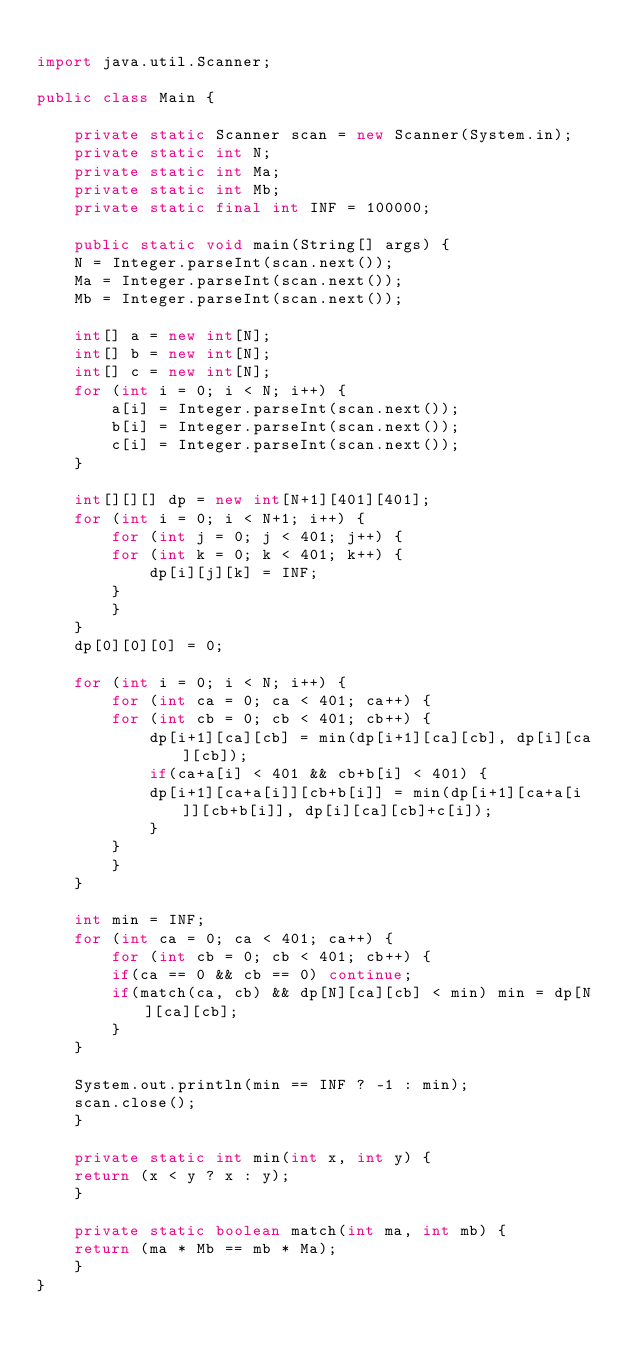Convert code to text. <code><loc_0><loc_0><loc_500><loc_500><_Java_>
import java.util.Scanner;

public class Main {

    private static Scanner scan = new Scanner(System.in);
    private static int N;
    private static int Ma;
    private static int Mb;
    private static final int INF = 100000;

    public static void main(String[] args) {
	N = Integer.parseInt(scan.next());
	Ma = Integer.parseInt(scan.next());
	Mb = Integer.parseInt(scan.next());

	int[] a = new int[N];
	int[] b = new int[N];
	int[] c = new int[N];
	for (int i = 0; i < N; i++) {
	    a[i] = Integer.parseInt(scan.next());
	    b[i] = Integer.parseInt(scan.next());
	    c[i] = Integer.parseInt(scan.next());
	}

	int[][][] dp = new int[N+1][401][401];
	for (int i = 0; i < N+1; i++) {
	    for (int j = 0; j < 401; j++) {
		for (int k = 0; k < 401; k++) {
		    dp[i][j][k] = INF;
		}
	    }
	}
	dp[0][0][0] = 0;

	for (int i = 0; i < N; i++) {
	    for (int ca = 0; ca < 401; ca++) {
		for (int cb = 0; cb < 401; cb++) {
		    dp[i+1][ca][cb] = min(dp[i+1][ca][cb], dp[i][ca][cb]);
		    if(ca+a[i] < 401 && cb+b[i] < 401) {
			dp[i+1][ca+a[i]][cb+b[i]] = min(dp[i+1][ca+a[i]][cb+b[i]], dp[i][ca][cb]+c[i]);
		    }
		}
	    }
	}

	int min = INF;
	for (int ca = 0; ca < 401; ca++) {
	    for (int cb = 0; cb < 401; cb++) {
		if(ca == 0 && cb == 0) continue;
		if(match(ca, cb) && dp[N][ca][cb] < min) min = dp[N][ca][cb];
	    }
	}

	System.out.println(min == INF ? -1 : min);
	scan.close();
    }

    private static int min(int x, int y) {
	return (x < y ? x : y);
    }

    private static boolean match(int ma, int mb) {
	return (ma * Mb == mb * Ma);
    }
}
</code> 